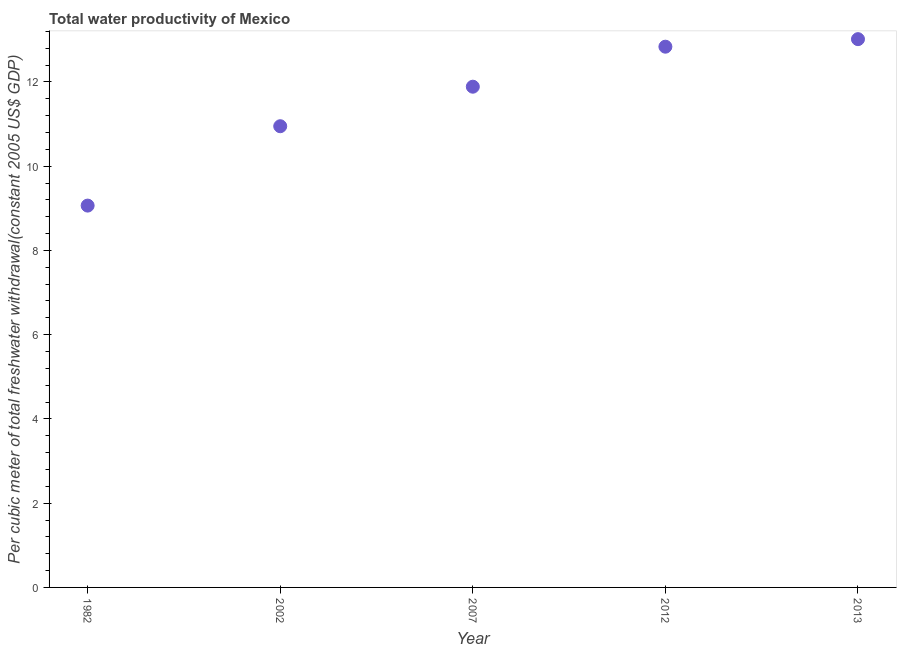What is the total water productivity in 2002?
Provide a succinct answer. 10.95. Across all years, what is the maximum total water productivity?
Provide a succinct answer. 13.02. Across all years, what is the minimum total water productivity?
Provide a succinct answer. 9.06. In which year was the total water productivity maximum?
Your response must be concise. 2013. In which year was the total water productivity minimum?
Offer a terse response. 1982. What is the sum of the total water productivity?
Offer a very short reply. 57.75. What is the difference between the total water productivity in 1982 and 2002?
Make the answer very short. -1.88. What is the average total water productivity per year?
Provide a succinct answer. 11.55. What is the median total water productivity?
Your answer should be compact. 11.89. In how many years, is the total water productivity greater than 8.4 US$?
Offer a terse response. 5. What is the ratio of the total water productivity in 1982 to that in 2007?
Provide a short and direct response. 0.76. Is the difference between the total water productivity in 2012 and 2013 greater than the difference between any two years?
Keep it short and to the point. No. What is the difference between the highest and the second highest total water productivity?
Your answer should be compact. 0.18. Is the sum of the total water productivity in 2012 and 2013 greater than the maximum total water productivity across all years?
Provide a succinct answer. Yes. What is the difference between the highest and the lowest total water productivity?
Give a very brief answer. 3.95. What is the difference between two consecutive major ticks on the Y-axis?
Your answer should be compact. 2. Are the values on the major ticks of Y-axis written in scientific E-notation?
Ensure brevity in your answer.  No. Does the graph contain any zero values?
Provide a succinct answer. No. What is the title of the graph?
Offer a very short reply. Total water productivity of Mexico. What is the label or title of the Y-axis?
Ensure brevity in your answer.  Per cubic meter of total freshwater withdrawal(constant 2005 US$ GDP). What is the Per cubic meter of total freshwater withdrawal(constant 2005 US$ GDP) in 1982?
Offer a terse response. 9.06. What is the Per cubic meter of total freshwater withdrawal(constant 2005 US$ GDP) in 2002?
Keep it short and to the point. 10.95. What is the Per cubic meter of total freshwater withdrawal(constant 2005 US$ GDP) in 2007?
Offer a terse response. 11.89. What is the Per cubic meter of total freshwater withdrawal(constant 2005 US$ GDP) in 2012?
Ensure brevity in your answer.  12.84. What is the Per cubic meter of total freshwater withdrawal(constant 2005 US$ GDP) in 2013?
Your answer should be very brief. 13.02. What is the difference between the Per cubic meter of total freshwater withdrawal(constant 2005 US$ GDP) in 1982 and 2002?
Your answer should be very brief. -1.88. What is the difference between the Per cubic meter of total freshwater withdrawal(constant 2005 US$ GDP) in 1982 and 2007?
Offer a terse response. -2.82. What is the difference between the Per cubic meter of total freshwater withdrawal(constant 2005 US$ GDP) in 1982 and 2012?
Keep it short and to the point. -3.77. What is the difference between the Per cubic meter of total freshwater withdrawal(constant 2005 US$ GDP) in 1982 and 2013?
Keep it short and to the point. -3.95. What is the difference between the Per cubic meter of total freshwater withdrawal(constant 2005 US$ GDP) in 2002 and 2007?
Ensure brevity in your answer.  -0.94. What is the difference between the Per cubic meter of total freshwater withdrawal(constant 2005 US$ GDP) in 2002 and 2012?
Your answer should be very brief. -1.89. What is the difference between the Per cubic meter of total freshwater withdrawal(constant 2005 US$ GDP) in 2002 and 2013?
Give a very brief answer. -2.07. What is the difference between the Per cubic meter of total freshwater withdrawal(constant 2005 US$ GDP) in 2007 and 2012?
Give a very brief answer. -0.95. What is the difference between the Per cubic meter of total freshwater withdrawal(constant 2005 US$ GDP) in 2007 and 2013?
Ensure brevity in your answer.  -1.13. What is the difference between the Per cubic meter of total freshwater withdrawal(constant 2005 US$ GDP) in 2012 and 2013?
Give a very brief answer. -0.18. What is the ratio of the Per cubic meter of total freshwater withdrawal(constant 2005 US$ GDP) in 1982 to that in 2002?
Provide a succinct answer. 0.83. What is the ratio of the Per cubic meter of total freshwater withdrawal(constant 2005 US$ GDP) in 1982 to that in 2007?
Your answer should be compact. 0.76. What is the ratio of the Per cubic meter of total freshwater withdrawal(constant 2005 US$ GDP) in 1982 to that in 2012?
Offer a very short reply. 0.71. What is the ratio of the Per cubic meter of total freshwater withdrawal(constant 2005 US$ GDP) in 1982 to that in 2013?
Offer a terse response. 0.7. What is the ratio of the Per cubic meter of total freshwater withdrawal(constant 2005 US$ GDP) in 2002 to that in 2007?
Offer a terse response. 0.92. What is the ratio of the Per cubic meter of total freshwater withdrawal(constant 2005 US$ GDP) in 2002 to that in 2012?
Keep it short and to the point. 0.85. What is the ratio of the Per cubic meter of total freshwater withdrawal(constant 2005 US$ GDP) in 2002 to that in 2013?
Give a very brief answer. 0.84. What is the ratio of the Per cubic meter of total freshwater withdrawal(constant 2005 US$ GDP) in 2007 to that in 2012?
Give a very brief answer. 0.93. What is the ratio of the Per cubic meter of total freshwater withdrawal(constant 2005 US$ GDP) in 2007 to that in 2013?
Give a very brief answer. 0.91. 